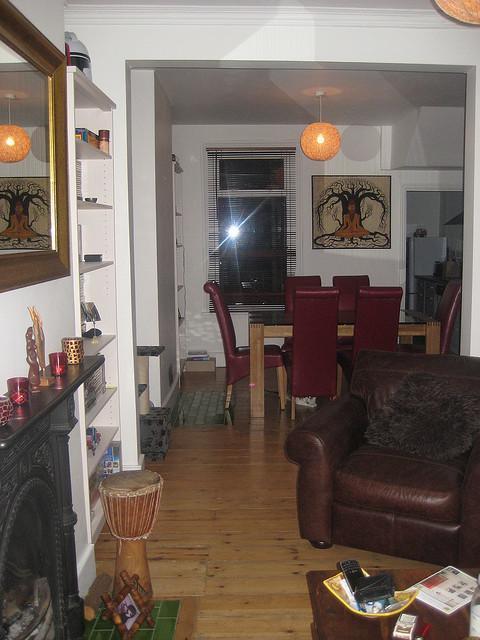How many chairs can be seen?
Give a very brief answer. 4. 